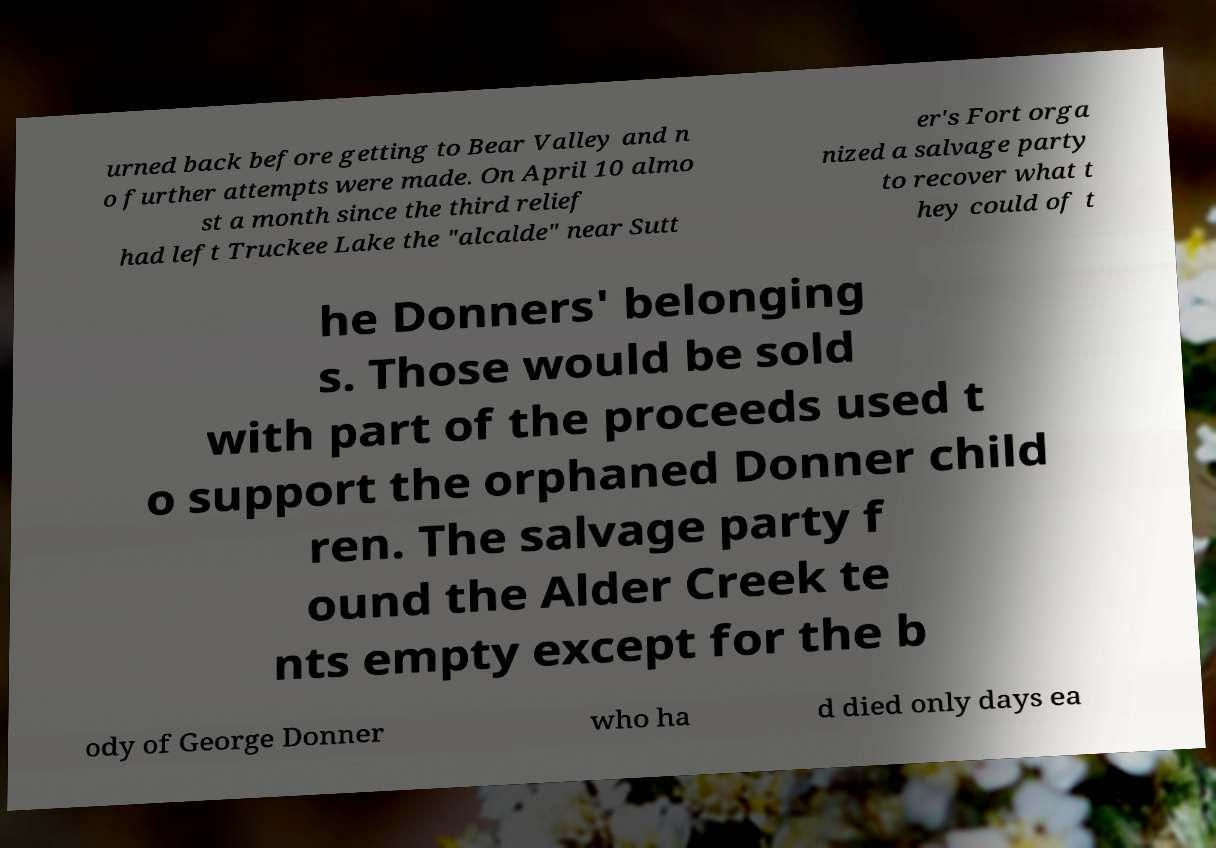There's text embedded in this image that I need extracted. Can you transcribe it verbatim? urned back before getting to Bear Valley and n o further attempts were made. On April 10 almo st a month since the third relief had left Truckee Lake the "alcalde" near Sutt er's Fort orga nized a salvage party to recover what t hey could of t he Donners' belonging s. Those would be sold with part of the proceeds used t o support the orphaned Donner child ren. The salvage party f ound the Alder Creek te nts empty except for the b ody of George Donner who ha d died only days ea 